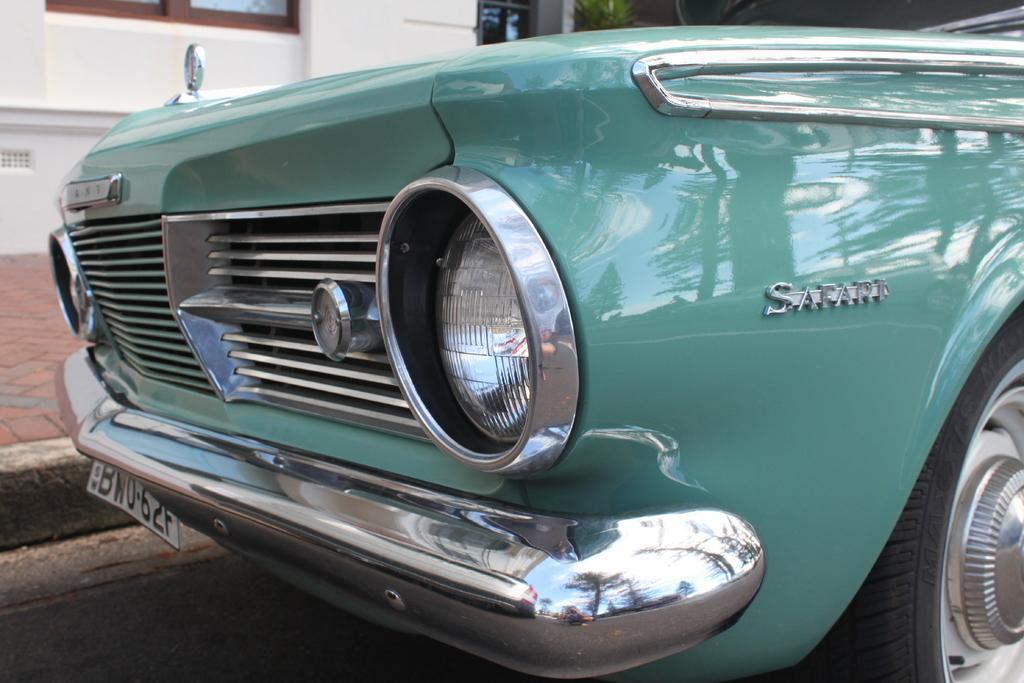Please provide a concise description of this image. The picture consists of a car. In the background there is a building. At the bottom it is road. 